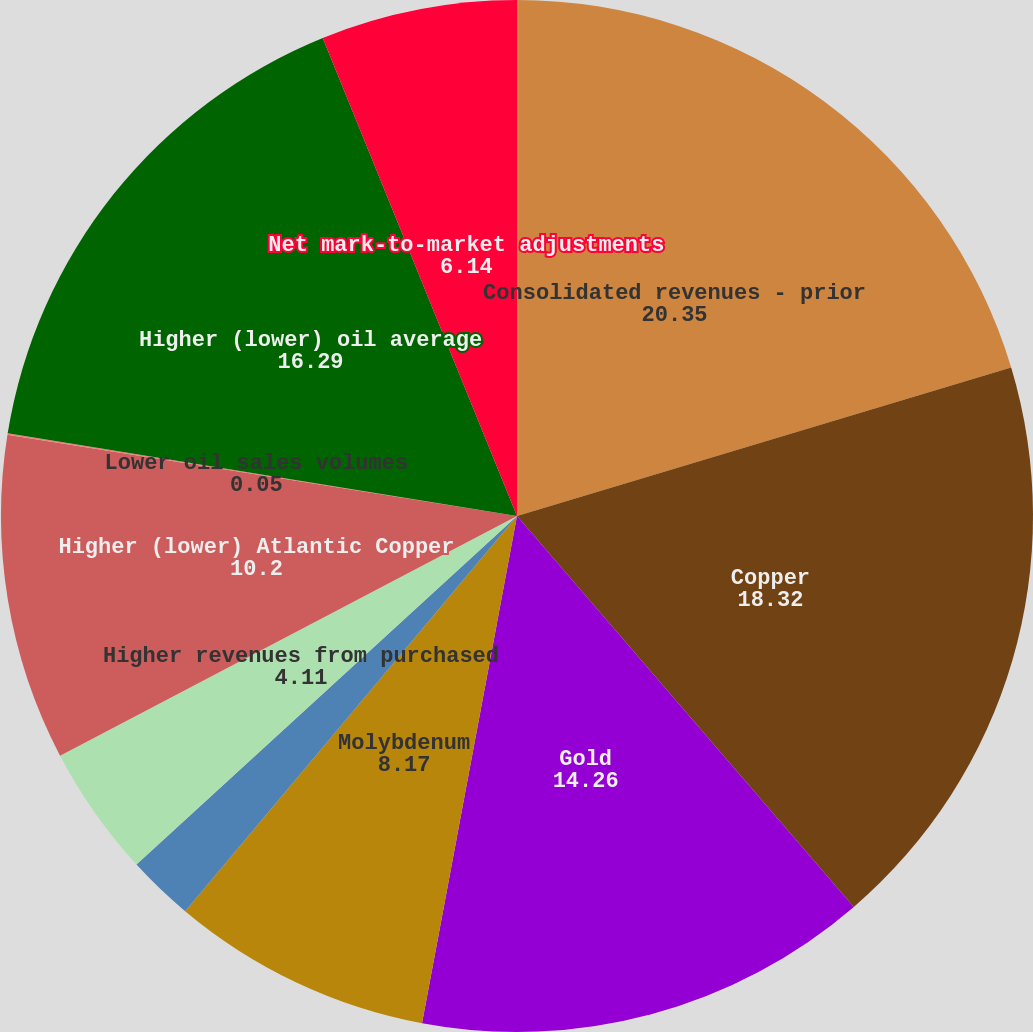Convert chart. <chart><loc_0><loc_0><loc_500><loc_500><pie_chart><fcel>Consolidated revenues - prior<fcel>Copper<fcel>Gold<fcel>Molybdenum<fcel>Net adjustments for prior year<fcel>Higher revenues from purchased<fcel>Higher (lower) Atlantic Copper<fcel>Lower oil sales volumes<fcel>Higher (lower) oil average<fcel>Net mark-to-market adjustments<nl><fcel>20.35%<fcel>18.32%<fcel>14.26%<fcel>8.17%<fcel>2.08%<fcel>4.11%<fcel>10.2%<fcel>0.05%<fcel>16.29%<fcel>6.14%<nl></chart> 